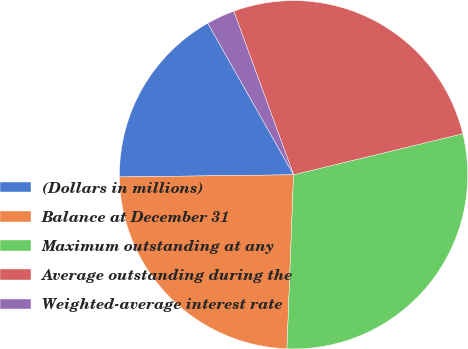<chart> <loc_0><loc_0><loc_500><loc_500><pie_chart><fcel>(Dollars in millions)<fcel>Balance at December 31<fcel>Maximum outstanding at any<fcel>Average outstanding during the<fcel>Weighted-average interest rate<nl><fcel>17.0%<fcel>24.2%<fcel>29.39%<fcel>26.79%<fcel>2.62%<nl></chart> 